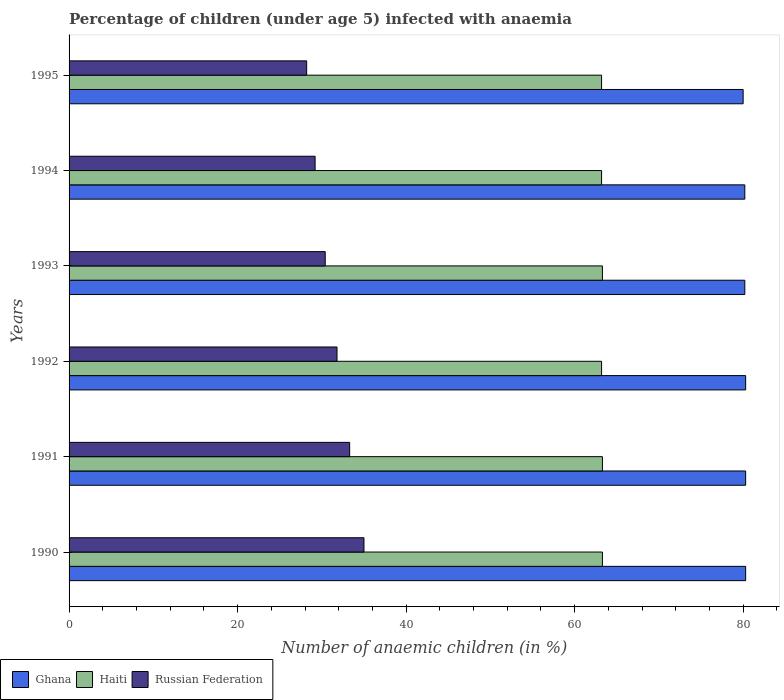How many bars are there on the 2nd tick from the top?
Offer a very short reply. 3. How many bars are there on the 4th tick from the bottom?
Offer a very short reply. 3. What is the percentage of children infected with anaemia in in Haiti in 1994?
Your answer should be very brief. 63.2. Across all years, what is the minimum percentage of children infected with anaemia in in Haiti?
Keep it short and to the point. 63.2. In which year was the percentage of children infected with anaemia in in Ghana minimum?
Ensure brevity in your answer.  1995. What is the total percentage of children infected with anaemia in in Haiti in the graph?
Offer a very short reply. 379.5. What is the difference between the percentage of children infected with anaemia in in Haiti in 1992 and that in 1994?
Keep it short and to the point. 0. What is the difference between the percentage of children infected with anaemia in in Haiti in 1992 and the percentage of children infected with anaemia in in Ghana in 1995?
Make the answer very short. -16.8. What is the average percentage of children infected with anaemia in in Haiti per year?
Your answer should be very brief. 63.25. In the year 1994, what is the difference between the percentage of children infected with anaemia in in Russian Federation and percentage of children infected with anaemia in in Ghana?
Your response must be concise. -51. In how many years, is the percentage of children infected with anaemia in in Ghana greater than 28 %?
Provide a short and direct response. 6. What is the ratio of the percentage of children infected with anaemia in in Russian Federation in 1990 to that in 1994?
Offer a terse response. 1.2. Is the difference between the percentage of children infected with anaemia in in Russian Federation in 1990 and 1992 greater than the difference between the percentage of children infected with anaemia in in Ghana in 1990 and 1992?
Make the answer very short. Yes. What is the difference between the highest and the lowest percentage of children infected with anaemia in in Russian Federation?
Offer a very short reply. 6.8. What does the 1st bar from the top in 1993 represents?
Your answer should be very brief. Russian Federation. What does the 1st bar from the bottom in 1991 represents?
Your answer should be compact. Ghana. How many bars are there?
Your answer should be very brief. 18. How many years are there in the graph?
Make the answer very short. 6. Where does the legend appear in the graph?
Your answer should be very brief. Bottom left. How many legend labels are there?
Offer a terse response. 3. How are the legend labels stacked?
Ensure brevity in your answer.  Horizontal. What is the title of the graph?
Ensure brevity in your answer.  Percentage of children (under age 5) infected with anaemia. Does "United States" appear as one of the legend labels in the graph?
Give a very brief answer. No. What is the label or title of the X-axis?
Provide a succinct answer. Number of anaemic children (in %). What is the Number of anaemic children (in %) of Ghana in 1990?
Make the answer very short. 80.3. What is the Number of anaemic children (in %) of Haiti in 1990?
Keep it short and to the point. 63.3. What is the Number of anaemic children (in %) of Russian Federation in 1990?
Give a very brief answer. 35. What is the Number of anaemic children (in %) in Ghana in 1991?
Give a very brief answer. 80.3. What is the Number of anaemic children (in %) of Haiti in 1991?
Provide a short and direct response. 63.3. What is the Number of anaemic children (in %) of Russian Federation in 1991?
Offer a terse response. 33.3. What is the Number of anaemic children (in %) of Ghana in 1992?
Your answer should be very brief. 80.3. What is the Number of anaemic children (in %) of Haiti in 1992?
Your answer should be very brief. 63.2. What is the Number of anaemic children (in %) in Russian Federation in 1992?
Your answer should be very brief. 31.8. What is the Number of anaemic children (in %) of Ghana in 1993?
Keep it short and to the point. 80.2. What is the Number of anaemic children (in %) of Haiti in 1993?
Your response must be concise. 63.3. What is the Number of anaemic children (in %) in Russian Federation in 1993?
Your answer should be very brief. 30.4. What is the Number of anaemic children (in %) in Ghana in 1994?
Your answer should be compact. 80.2. What is the Number of anaemic children (in %) of Haiti in 1994?
Keep it short and to the point. 63.2. What is the Number of anaemic children (in %) in Russian Federation in 1994?
Keep it short and to the point. 29.2. What is the Number of anaemic children (in %) in Haiti in 1995?
Your answer should be compact. 63.2. What is the Number of anaemic children (in %) of Russian Federation in 1995?
Offer a very short reply. 28.2. Across all years, what is the maximum Number of anaemic children (in %) in Ghana?
Give a very brief answer. 80.3. Across all years, what is the maximum Number of anaemic children (in %) of Haiti?
Make the answer very short. 63.3. Across all years, what is the minimum Number of anaemic children (in %) in Haiti?
Provide a succinct answer. 63.2. Across all years, what is the minimum Number of anaemic children (in %) of Russian Federation?
Your answer should be compact. 28.2. What is the total Number of anaemic children (in %) in Ghana in the graph?
Your response must be concise. 481.3. What is the total Number of anaemic children (in %) in Haiti in the graph?
Provide a succinct answer. 379.5. What is the total Number of anaemic children (in %) in Russian Federation in the graph?
Give a very brief answer. 187.9. What is the difference between the Number of anaemic children (in %) of Ghana in 1990 and that in 1991?
Provide a succinct answer. 0. What is the difference between the Number of anaemic children (in %) of Russian Federation in 1990 and that in 1991?
Your answer should be compact. 1.7. What is the difference between the Number of anaemic children (in %) of Haiti in 1990 and that in 1992?
Your answer should be compact. 0.1. What is the difference between the Number of anaemic children (in %) of Haiti in 1990 and that in 1993?
Ensure brevity in your answer.  0. What is the difference between the Number of anaemic children (in %) in Russian Federation in 1990 and that in 1993?
Provide a short and direct response. 4.6. What is the difference between the Number of anaemic children (in %) in Russian Federation in 1990 and that in 1994?
Give a very brief answer. 5.8. What is the difference between the Number of anaemic children (in %) of Haiti in 1990 and that in 1995?
Provide a short and direct response. 0.1. What is the difference between the Number of anaemic children (in %) of Ghana in 1991 and that in 1993?
Your response must be concise. 0.1. What is the difference between the Number of anaemic children (in %) in Haiti in 1991 and that in 1993?
Make the answer very short. 0. What is the difference between the Number of anaemic children (in %) of Haiti in 1992 and that in 1993?
Your answer should be very brief. -0.1. What is the difference between the Number of anaemic children (in %) in Russian Federation in 1992 and that in 1993?
Keep it short and to the point. 1.4. What is the difference between the Number of anaemic children (in %) in Ghana in 1992 and that in 1994?
Offer a very short reply. 0.1. What is the difference between the Number of anaemic children (in %) in Haiti in 1992 and that in 1994?
Your answer should be very brief. 0. What is the difference between the Number of anaemic children (in %) in Haiti in 1992 and that in 1995?
Give a very brief answer. 0. What is the difference between the Number of anaemic children (in %) in Ghana in 1993 and that in 1995?
Your response must be concise. 0.2. What is the difference between the Number of anaemic children (in %) of Haiti in 1993 and that in 1995?
Offer a very short reply. 0.1. What is the difference between the Number of anaemic children (in %) of Russian Federation in 1993 and that in 1995?
Offer a terse response. 2.2. What is the difference between the Number of anaemic children (in %) in Ghana in 1994 and that in 1995?
Keep it short and to the point. 0.2. What is the difference between the Number of anaemic children (in %) of Ghana in 1990 and the Number of anaemic children (in %) of Russian Federation in 1992?
Keep it short and to the point. 48.5. What is the difference between the Number of anaemic children (in %) in Haiti in 1990 and the Number of anaemic children (in %) in Russian Federation in 1992?
Provide a short and direct response. 31.5. What is the difference between the Number of anaemic children (in %) in Ghana in 1990 and the Number of anaemic children (in %) in Haiti in 1993?
Give a very brief answer. 17. What is the difference between the Number of anaemic children (in %) in Ghana in 1990 and the Number of anaemic children (in %) in Russian Federation in 1993?
Make the answer very short. 49.9. What is the difference between the Number of anaemic children (in %) in Haiti in 1990 and the Number of anaemic children (in %) in Russian Federation in 1993?
Your response must be concise. 32.9. What is the difference between the Number of anaemic children (in %) of Ghana in 1990 and the Number of anaemic children (in %) of Russian Federation in 1994?
Offer a terse response. 51.1. What is the difference between the Number of anaemic children (in %) in Haiti in 1990 and the Number of anaemic children (in %) in Russian Federation in 1994?
Ensure brevity in your answer.  34.1. What is the difference between the Number of anaemic children (in %) of Ghana in 1990 and the Number of anaemic children (in %) of Haiti in 1995?
Give a very brief answer. 17.1. What is the difference between the Number of anaemic children (in %) of Ghana in 1990 and the Number of anaemic children (in %) of Russian Federation in 1995?
Make the answer very short. 52.1. What is the difference between the Number of anaemic children (in %) of Haiti in 1990 and the Number of anaemic children (in %) of Russian Federation in 1995?
Offer a terse response. 35.1. What is the difference between the Number of anaemic children (in %) of Ghana in 1991 and the Number of anaemic children (in %) of Russian Federation in 1992?
Make the answer very short. 48.5. What is the difference between the Number of anaemic children (in %) in Haiti in 1991 and the Number of anaemic children (in %) in Russian Federation in 1992?
Give a very brief answer. 31.5. What is the difference between the Number of anaemic children (in %) of Ghana in 1991 and the Number of anaemic children (in %) of Russian Federation in 1993?
Provide a succinct answer. 49.9. What is the difference between the Number of anaemic children (in %) in Haiti in 1991 and the Number of anaemic children (in %) in Russian Federation in 1993?
Offer a terse response. 32.9. What is the difference between the Number of anaemic children (in %) in Ghana in 1991 and the Number of anaemic children (in %) in Russian Federation in 1994?
Provide a succinct answer. 51.1. What is the difference between the Number of anaemic children (in %) of Haiti in 1991 and the Number of anaemic children (in %) of Russian Federation in 1994?
Keep it short and to the point. 34.1. What is the difference between the Number of anaemic children (in %) of Ghana in 1991 and the Number of anaemic children (in %) of Haiti in 1995?
Provide a short and direct response. 17.1. What is the difference between the Number of anaemic children (in %) in Ghana in 1991 and the Number of anaemic children (in %) in Russian Federation in 1995?
Your response must be concise. 52.1. What is the difference between the Number of anaemic children (in %) in Haiti in 1991 and the Number of anaemic children (in %) in Russian Federation in 1995?
Your response must be concise. 35.1. What is the difference between the Number of anaemic children (in %) in Ghana in 1992 and the Number of anaemic children (in %) in Russian Federation in 1993?
Ensure brevity in your answer.  49.9. What is the difference between the Number of anaemic children (in %) in Haiti in 1992 and the Number of anaemic children (in %) in Russian Federation in 1993?
Provide a succinct answer. 32.8. What is the difference between the Number of anaemic children (in %) of Ghana in 1992 and the Number of anaemic children (in %) of Haiti in 1994?
Provide a succinct answer. 17.1. What is the difference between the Number of anaemic children (in %) of Ghana in 1992 and the Number of anaemic children (in %) of Russian Federation in 1994?
Keep it short and to the point. 51.1. What is the difference between the Number of anaemic children (in %) of Ghana in 1992 and the Number of anaemic children (in %) of Haiti in 1995?
Keep it short and to the point. 17.1. What is the difference between the Number of anaemic children (in %) of Ghana in 1992 and the Number of anaemic children (in %) of Russian Federation in 1995?
Your answer should be compact. 52.1. What is the difference between the Number of anaemic children (in %) in Ghana in 1993 and the Number of anaemic children (in %) in Haiti in 1994?
Keep it short and to the point. 17. What is the difference between the Number of anaemic children (in %) in Haiti in 1993 and the Number of anaemic children (in %) in Russian Federation in 1994?
Your response must be concise. 34.1. What is the difference between the Number of anaemic children (in %) of Ghana in 1993 and the Number of anaemic children (in %) of Haiti in 1995?
Your answer should be compact. 17. What is the difference between the Number of anaemic children (in %) in Haiti in 1993 and the Number of anaemic children (in %) in Russian Federation in 1995?
Give a very brief answer. 35.1. What is the difference between the Number of anaemic children (in %) of Ghana in 1994 and the Number of anaemic children (in %) of Russian Federation in 1995?
Ensure brevity in your answer.  52. What is the difference between the Number of anaemic children (in %) of Haiti in 1994 and the Number of anaemic children (in %) of Russian Federation in 1995?
Your response must be concise. 35. What is the average Number of anaemic children (in %) of Ghana per year?
Your answer should be compact. 80.22. What is the average Number of anaemic children (in %) in Haiti per year?
Provide a short and direct response. 63.25. What is the average Number of anaemic children (in %) in Russian Federation per year?
Provide a succinct answer. 31.32. In the year 1990, what is the difference between the Number of anaemic children (in %) of Ghana and Number of anaemic children (in %) of Russian Federation?
Ensure brevity in your answer.  45.3. In the year 1990, what is the difference between the Number of anaemic children (in %) in Haiti and Number of anaemic children (in %) in Russian Federation?
Offer a terse response. 28.3. In the year 1991, what is the difference between the Number of anaemic children (in %) of Haiti and Number of anaemic children (in %) of Russian Federation?
Provide a short and direct response. 30. In the year 1992, what is the difference between the Number of anaemic children (in %) in Ghana and Number of anaemic children (in %) in Haiti?
Your answer should be compact. 17.1. In the year 1992, what is the difference between the Number of anaemic children (in %) of Ghana and Number of anaemic children (in %) of Russian Federation?
Provide a short and direct response. 48.5. In the year 1992, what is the difference between the Number of anaemic children (in %) of Haiti and Number of anaemic children (in %) of Russian Federation?
Provide a succinct answer. 31.4. In the year 1993, what is the difference between the Number of anaemic children (in %) in Ghana and Number of anaemic children (in %) in Russian Federation?
Your response must be concise. 49.8. In the year 1993, what is the difference between the Number of anaemic children (in %) of Haiti and Number of anaemic children (in %) of Russian Federation?
Your answer should be very brief. 32.9. In the year 1994, what is the difference between the Number of anaemic children (in %) in Haiti and Number of anaemic children (in %) in Russian Federation?
Offer a terse response. 34. In the year 1995, what is the difference between the Number of anaemic children (in %) of Ghana and Number of anaemic children (in %) of Haiti?
Keep it short and to the point. 16.8. In the year 1995, what is the difference between the Number of anaemic children (in %) in Ghana and Number of anaemic children (in %) in Russian Federation?
Your answer should be very brief. 51.8. In the year 1995, what is the difference between the Number of anaemic children (in %) of Haiti and Number of anaemic children (in %) of Russian Federation?
Keep it short and to the point. 35. What is the ratio of the Number of anaemic children (in %) in Ghana in 1990 to that in 1991?
Provide a short and direct response. 1. What is the ratio of the Number of anaemic children (in %) of Russian Federation in 1990 to that in 1991?
Make the answer very short. 1.05. What is the ratio of the Number of anaemic children (in %) of Ghana in 1990 to that in 1992?
Ensure brevity in your answer.  1. What is the ratio of the Number of anaemic children (in %) of Russian Federation in 1990 to that in 1992?
Your response must be concise. 1.1. What is the ratio of the Number of anaemic children (in %) in Ghana in 1990 to that in 1993?
Your answer should be compact. 1. What is the ratio of the Number of anaemic children (in %) in Russian Federation in 1990 to that in 1993?
Your answer should be very brief. 1.15. What is the ratio of the Number of anaemic children (in %) of Ghana in 1990 to that in 1994?
Provide a short and direct response. 1. What is the ratio of the Number of anaemic children (in %) in Haiti in 1990 to that in 1994?
Ensure brevity in your answer.  1. What is the ratio of the Number of anaemic children (in %) of Russian Federation in 1990 to that in 1994?
Your answer should be very brief. 1.2. What is the ratio of the Number of anaemic children (in %) of Russian Federation in 1990 to that in 1995?
Offer a terse response. 1.24. What is the ratio of the Number of anaemic children (in %) in Ghana in 1991 to that in 1992?
Provide a succinct answer. 1. What is the ratio of the Number of anaemic children (in %) in Russian Federation in 1991 to that in 1992?
Provide a short and direct response. 1.05. What is the ratio of the Number of anaemic children (in %) of Ghana in 1991 to that in 1993?
Offer a terse response. 1. What is the ratio of the Number of anaemic children (in %) of Russian Federation in 1991 to that in 1993?
Your answer should be compact. 1.1. What is the ratio of the Number of anaemic children (in %) of Russian Federation in 1991 to that in 1994?
Provide a succinct answer. 1.14. What is the ratio of the Number of anaemic children (in %) in Ghana in 1991 to that in 1995?
Ensure brevity in your answer.  1. What is the ratio of the Number of anaemic children (in %) of Haiti in 1991 to that in 1995?
Offer a terse response. 1. What is the ratio of the Number of anaemic children (in %) of Russian Federation in 1991 to that in 1995?
Your answer should be very brief. 1.18. What is the ratio of the Number of anaemic children (in %) of Ghana in 1992 to that in 1993?
Make the answer very short. 1. What is the ratio of the Number of anaemic children (in %) of Haiti in 1992 to that in 1993?
Provide a short and direct response. 1. What is the ratio of the Number of anaemic children (in %) of Russian Federation in 1992 to that in 1993?
Your answer should be compact. 1.05. What is the ratio of the Number of anaemic children (in %) in Haiti in 1992 to that in 1994?
Provide a succinct answer. 1. What is the ratio of the Number of anaemic children (in %) in Russian Federation in 1992 to that in 1994?
Your answer should be compact. 1.09. What is the ratio of the Number of anaemic children (in %) in Ghana in 1992 to that in 1995?
Your answer should be very brief. 1. What is the ratio of the Number of anaemic children (in %) of Haiti in 1992 to that in 1995?
Offer a terse response. 1. What is the ratio of the Number of anaemic children (in %) in Russian Federation in 1992 to that in 1995?
Offer a terse response. 1.13. What is the ratio of the Number of anaemic children (in %) in Ghana in 1993 to that in 1994?
Provide a short and direct response. 1. What is the ratio of the Number of anaemic children (in %) of Russian Federation in 1993 to that in 1994?
Provide a short and direct response. 1.04. What is the ratio of the Number of anaemic children (in %) in Ghana in 1993 to that in 1995?
Provide a short and direct response. 1. What is the ratio of the Number of anaemic children (in %) of Haiti in 1993 to that in 1995?
Your answer should be compact. 1. What is the ratio of the Number of anaemic children (in %) of Russian Federation in 1993 to that in 1995?
Keep it short and to the point. 1.08. What is the ratio of the Number of anaemic children (in %) in Russian Federation in 1994 to that in 1995?
Make the answer very short. 1.04. What is the difference between the highest and the second highest Number of anaemic children (in %) in Russian Federation?
Provide a short and direct response. 1.7. 